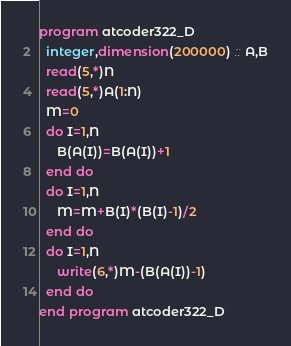<code> <loc_0><loc_0><loc_500><loc_500><_FORTRAN_>program atcoder322_D
  integer,dimension(200000) :: A,B
  read(5,*)N
  read(5,*)A(1:N)
  M=0
  do I=1,N
     B(A(I))=B(A(I))+1
  end do
  do I=1,N
     M=M+B(I)*(B(I)-1)/2
  end do
  do I=1,N
     write(6,*)M-(B(A(I))-1)
  end do
end program atcoder322_D</code> 